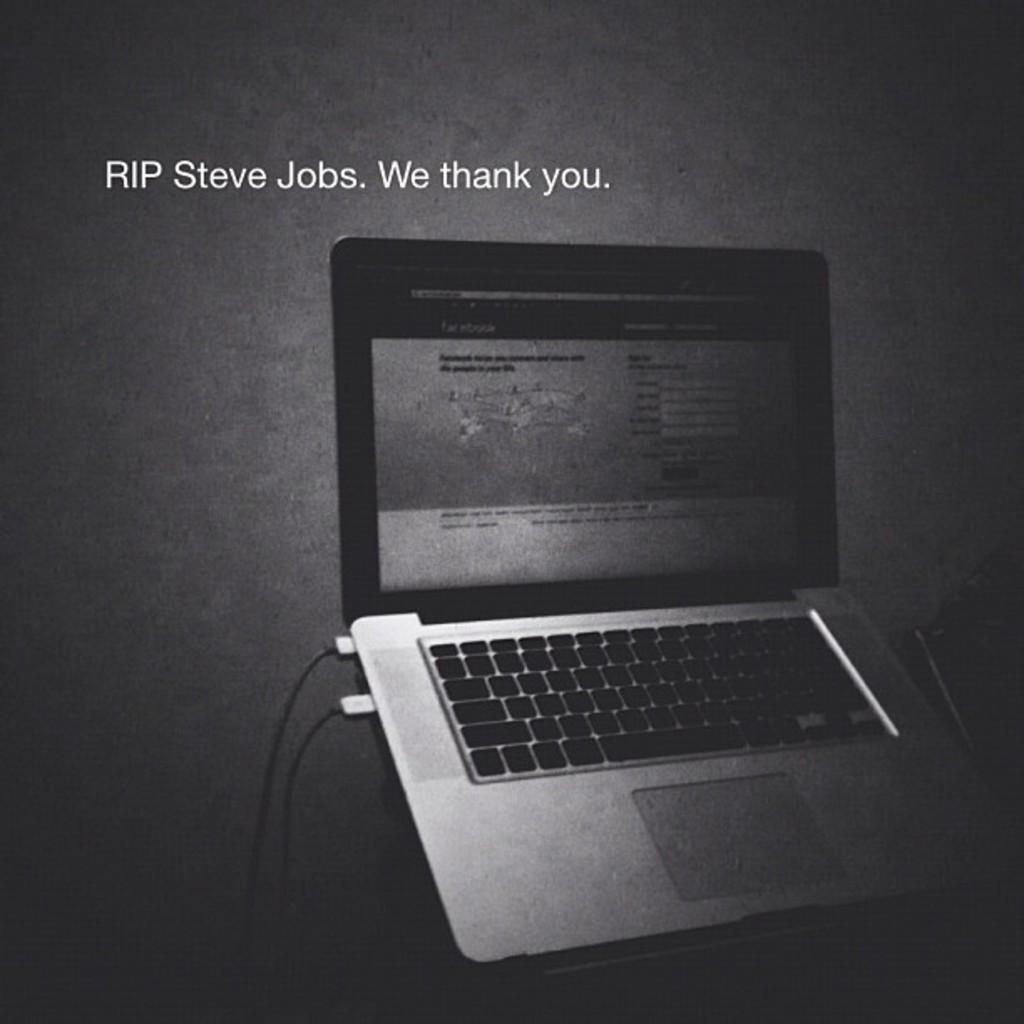<image>
Render a clear and concise summary of the photo. Ad for Macbook Pro saying that they thank us. 